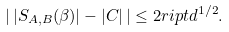<formula> <loc_0><loc_0><loc_500><loc_500>\left | \, | S _ { A , B } ( \beta ) | - | C | \, \right | \leq 2 r i p t d ^ { 1 / 2 } .</formula> 